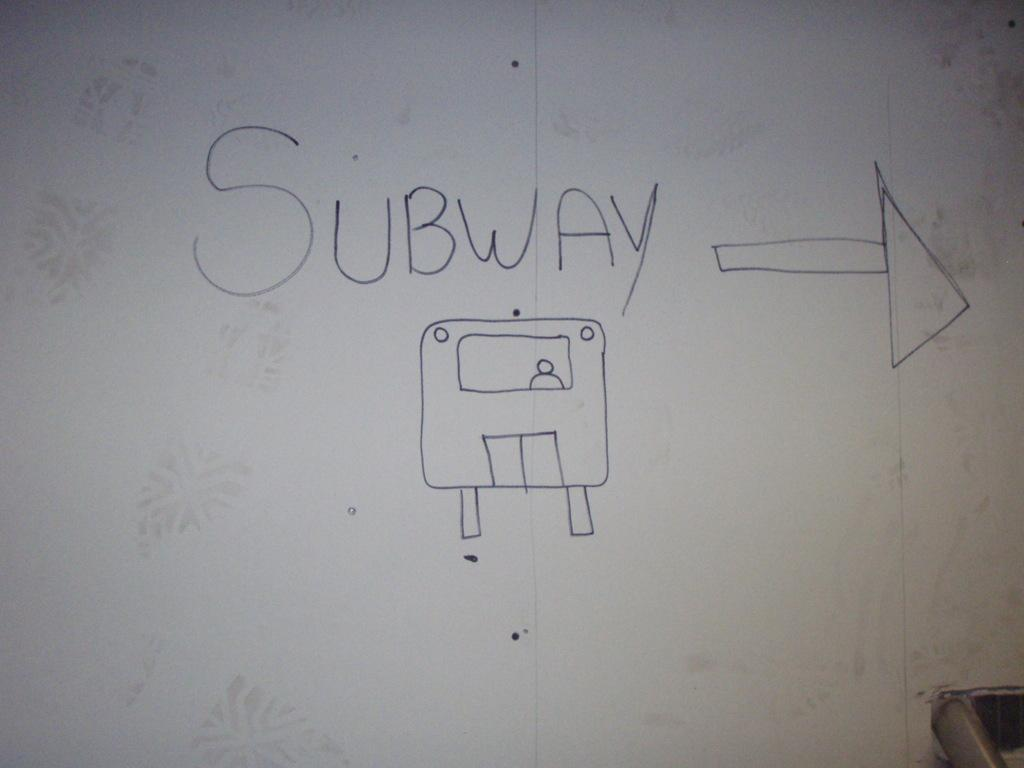<image>
Summarize the visual content of the image. A white board with the word Subway written on it. 